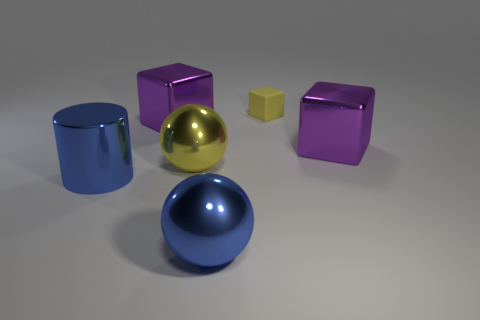What is the size of the yellow thing that is on the right side of the large blue metal ball?
Provide a succinct answer. Small. There is a yellow rubber thing; does it have the same size as the purple block that is to the right of the tiny yellow rubber cube?
Make the answer very short. No. Is the number of matte things in front of the large blue sphere less than the number of purple metal cubes?
Provide a short and direct response. Yes. There is another large object that is the same shape as the large yellow object; what is its material?
Make the answer very short. Metal. There is a big metal thing that is right of the blue cylinder and in front of the big yellow metallic sphere; what is its shape?
Provide a succinct answer. Sphere. There is a yellow thing that is the same material as the blue sphere; what is its shape?
Your answer should be compact. Sphere. What material is the big purple cube that is to the left of the big yellow ball?
Your answer should be compact. Metal. There is a metallic object that is in front of the cylinder; does it have the same size as the yellow object behind the yellow metal thing?
Your response must be concise. No. What is the color of the big metal cylinder?
Offer a terse response. Blue. There is a large metal object on the right side of the yellow block; does it have the same shape as the small thing?
Provide a short and direct response. Yes. 